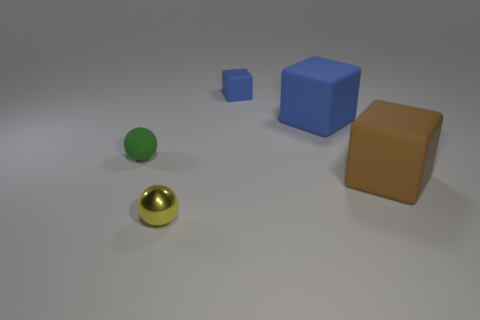There is a large matte block that is behind the rubber ball; does it have the same color as the rubber object left of the shiny thing?
Your answer should be very brief. No. How many green things are either large things or rubber balls?
Give a very brief answer. 1. What number of rubber blocks have the same size as the brown matte thing?
Offer a very short reply. 1. Are the large thing behind the small green object and the green ball made of the same material?
Your response must be concise. Yes. There is a blue cube that is in front of the small blue object; are there any matte blocks that are behind it?
Keep it short and to the point. Yes. What is the material of the small green object that is the same shape as the small yellow thing?
Ensure brevity in your answer.  Rubber. Are there more tiny rubber spheres behind the tiny yellow sphere than brown matte objects on the left side of the large brown matte thing?
Make the answer very short. Yes. There is a tiny blue thing that is made of the same material as the brown thing; what is its shape?
Provide a succinct answer. Cube. Is the number of big things in front of the rubber sphere greater than the number of big yellow shiny objects?
Make the answer very short. Yes. What number of big matte objects have the same color as the small rubber cube?
Ensure brevity in your answer.  1. 